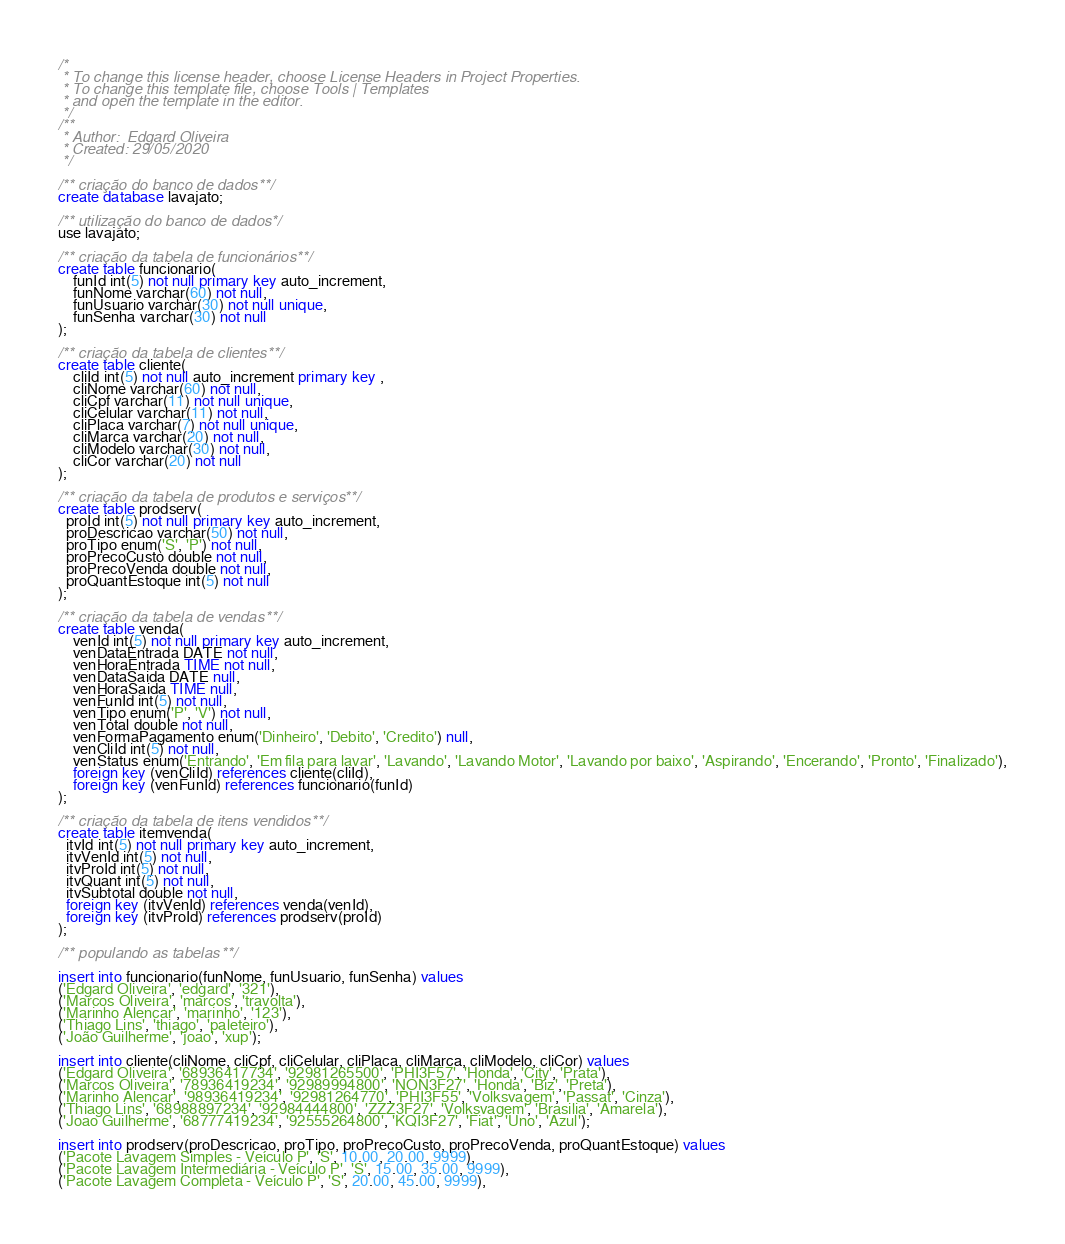<code> <loc_0><loc_0><loc_500><loc_500><_SQL_>/* 
 * To change this license header, choose License Headers in Project Properties.
 * To change this template file, choose Tools | Templates
 * and open the template in the editor.
 */
/**
 * Author:  Edgard Oliveira
 * Created: 29/05/2020
 */

/** criação do banco de dados **/
create database lavajato;

/** utilização do banco de dados */
use lavajato;

/** criação da tabela de funcionários **/
create table funcionario(
    funId int(5) not null primary key auto_increment,
    funNome varchar(60) not null,
    funUsuario varchar(30) not null unique,
    funSenha varchar(30) not null
);

/** criação da tabela de clientes **/
create table cliente(
    cliId int(5) not null auto_increment primary key ,
    cliNome varchar(60) not null,
    cliCpf varchar(11) not null unique,
    cliCelular varchar(11) not null,
    cliPlaca varchar(7) not null unique,
    cliMarca varchar(20) not null,
    cliModelo varchar(30) not null,
    cliCor varchar(20) not null
);

/** criação da tabela de produtos e serviços **/
create table prodserv(
  proId int(5) not null primary key auto_increment,
  proDescricao varchar(50) not null,
  proTipo enum('S', 'P') not null,
  proPrecoCusto double not null,
  proPrecoVenda double not null,
  proQuantEstoque int(5) not null
);

/** criação da tabela de vendas **/
create table venda(
    venId int(5) not null primary key auto_increment,
    venDataEntrada DATE not null,
    venHoraEntrada TIME not null,
    venDataSaida DATE null,
    venHoraSaida TIME null,
    venFunId int(5) not null,
    venTipo enum('P', 'V') not null,
    venTotal double not null,
    venFormaPagamento enum('Dinheiro', 'Debito', 'Credito') null,
    venCliId int(5) not null,
    venStatus enum('Entrando', 'Em fila para lavar', 'Lavando', 'Lavando Motor', 'Lavando por baixo', 'Aspirando', 'Encerando', 'Pronto', 'Finalizado'),
    foreign key (venCliId) references cliente(cliId),
    foreign key (venFunId) references funcionario(funId)
);

/** criação da tabela de itens vendidos **/
create table itemvenda(
  itvId int(5) not null primary key auto_increment,
  itvVenId int(5) not null,
  itvProId int(5) not null,
  itvQuant int(5) not null,
  itvSubtotal double not null,
  foreign key (itvVenId) references venda(venId),
  foreign key (itvProId) references prodserv(proId)
);

/** populando as tabelas **/

insert into funcionario(funNome, funUsuario, funSenha) values
('Edgard Oliveira', 'edgard', '321'),
('Marcos Oliveira', 'marcos', 'travolta'),
('Marinho Alencar', 'marinho', '123'),
('Thiago Lins', 'thiago', 'paleteiro'),
('João Guilherme', 'joao', 'xup');

insert into cliente(cliNome, cliCpf, cliCelular, cliPlaca, cliMarca, cliModelo, cliCor) values
('Edgard Oliveira', '68936417734', '92981265500', 'PHI3F57', 'Honda', 'City', 'Prata'),
('Marcos Oliveira', '78936419234', '92989994800', 'NON3F27', 'Honda', 'Biz', 'Preta'),
('Marinho Alencar', '98936419234', '92981264770', 'PHI3F55', 'Volksvagem', 'Passat', 'Cinza'),
('Thiago Lins', '68988897234', '92984444800', 'ZZZ3F27', 'Volksvagem', 'Brasilia', 'Amarela'),
('Joao Guilherme', '68777419234', '92555264800', 'KQI3F27', 'Fiat', 'Uno', 'Azul');

insert into prodserv(proDescricao, proTipo, proPrecoCusto, proPrecoVenda, proQuantEstoque) values
('Pacote Lavagem Simples - Veículo P', 'S', 10.00, 20.00, 9999),
('Pacote Lavagem Intermediária - Veículo P', 'S', 15.00, 35.00, 9999),
('Pacote Lavagem Completa - Veículo P', 'S', 20.00, 45.00, 9999),</code> 